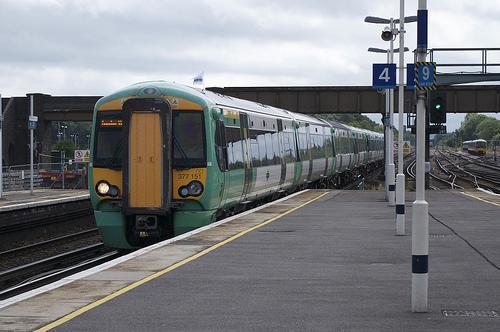How many lights are on the train?
Give a very brief answer. 1. 